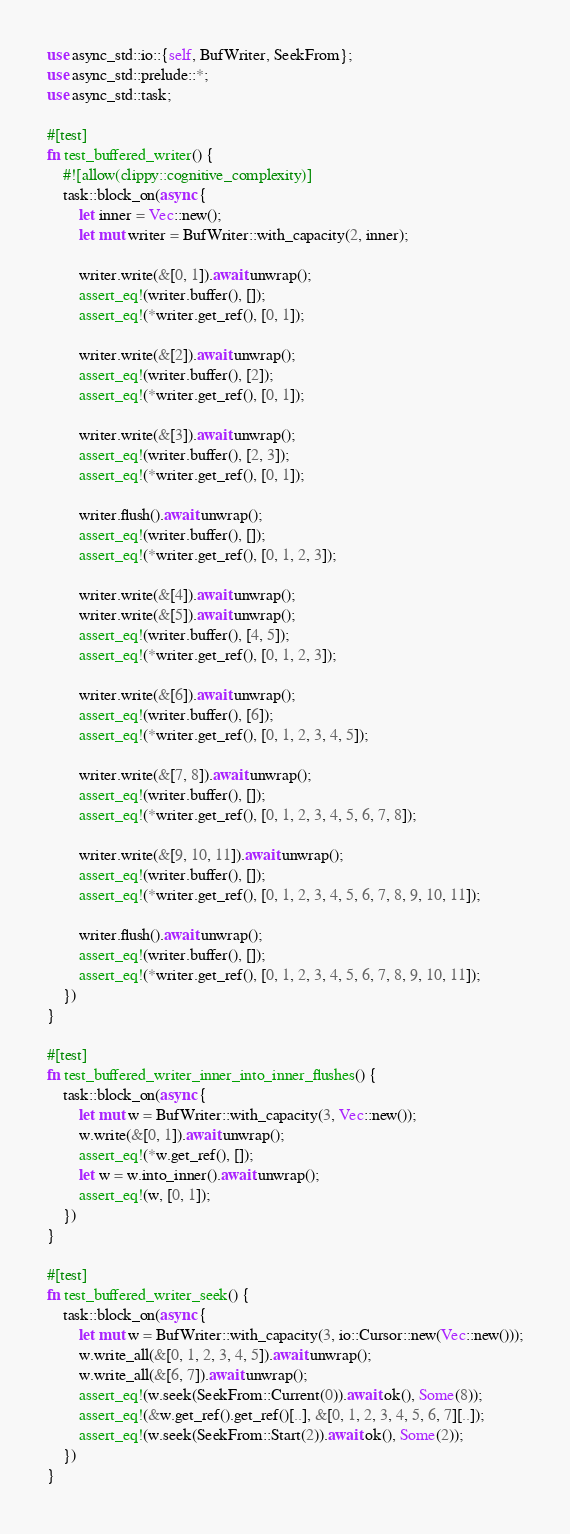Convert code to text. <code><loc_0><loc_0><loc_500><loc_500><_Rust_>use async_std::io::{self, BufWriter, SeekFrom};
use async_std::prelude::*;
use async_std::task;

#[test]
fn test_buffered_writer() {
    #![allow(clippy::cognitive_complexity)]
    task::block_on(async {
        let inner = Vec::new();
        let mut writer = BufWriter::with_capacity(2, inner);

        writer.write(&[0, 1]).await.unwrap();
        assert_eq!(writer.buffer(), []);
        assert_eq!(*writer.get_ref(), [0, 1]);

        writer.write(&[2]).await.unwrap();
        assert_eq!(writer.buffer(), [2]);
        assert_eq!(*writer.get_ref(), [0, 1]);

        writer.write(&[3]).await.unwrap();
        assert_eq!(writer.buffer(), [2, 3]);
        assert_eq!(*writer.get_ref(), [0, 1]);

        writer.flush().await.unwrap();
        assert_eq!(writer.buffer(), []);
        assert_eq!(*writer.get_ref(), [0, 1, 2, 3]);

        writer.write(&[4]).await.unwrap();
        writer.write(&[5]).await.unwrap();
        assert_eq!(writer.buffer(), [4, 5]);
        assert_eq!(*writer.get_ref(), [0, 1, 2, 3]);

        writer.write(&[6]).await.unwrap();
        assert_eq!(writer.buffer(), [6]);
        assert_eq!(*writer.get_ref(), [0, 1, 2, 3, 4, 5]);

        writer.write(&[7, 8]).await.unwrap();
        assert_eq!(writer.buffer(), []);
        assert_eq!(*writer.get_ref(), [0, 1, 2, 3, 4, 5, 6, 7, 8]);

        writer.write(&[9, 10, 11]).await.unwrap();
        assert_eq!(writer.buffer(), []);
        assert_eq!(*writer.get_ref(), [0, 1, 2, 3, 4, 5, 6, 7, 8, 9, 10, 11]);

        writer.flush().await.unwrap();
        assert_eq!(writer.buffer(), []);
        assert_eq!(*writer.get_ref(), [0, 1, 2, 3, 4, 5, 6, 7, 8, 9, 10, 11]);
    })
}

#[test]
fn test_buffered_writer_inner_into_inner_flushes() {
    task::block_on(async {
        let mut w = BufWriter::with_capacity(3, Vec::new());
        w.write(&[0, 1]).await.unwrap();
        assert_eq!(*w.get_ref(), []);
        let w = w.into_inner().await.unwrap();
        assert_eq!(w, [0, 1]);
    })
}

#[test]
fn test_buffered_writer_seek() {
    task::block_on(async {
        let mut w = BufWriter::with_capacity(3, io::Cursor::new(Vec::new()));
        w.write_all(&[0, 1, 2, 3, 4, 5]).await.unwrap();
        w.write_all(&[6, 7]).await.unwrap();
        assert_eq!(w.seek(SeekFrom::Current(0)).await.ok(), Some(8));
        assert_eq!(&w.get_ref().get_ref()[..], &[0, 1, 2, 3, 4, 5, 6, 7][..]);
        assert_eq!(w.seek(SeekFrom::Start(2)).await.ok(), Some(2));
    })
}
</code> 